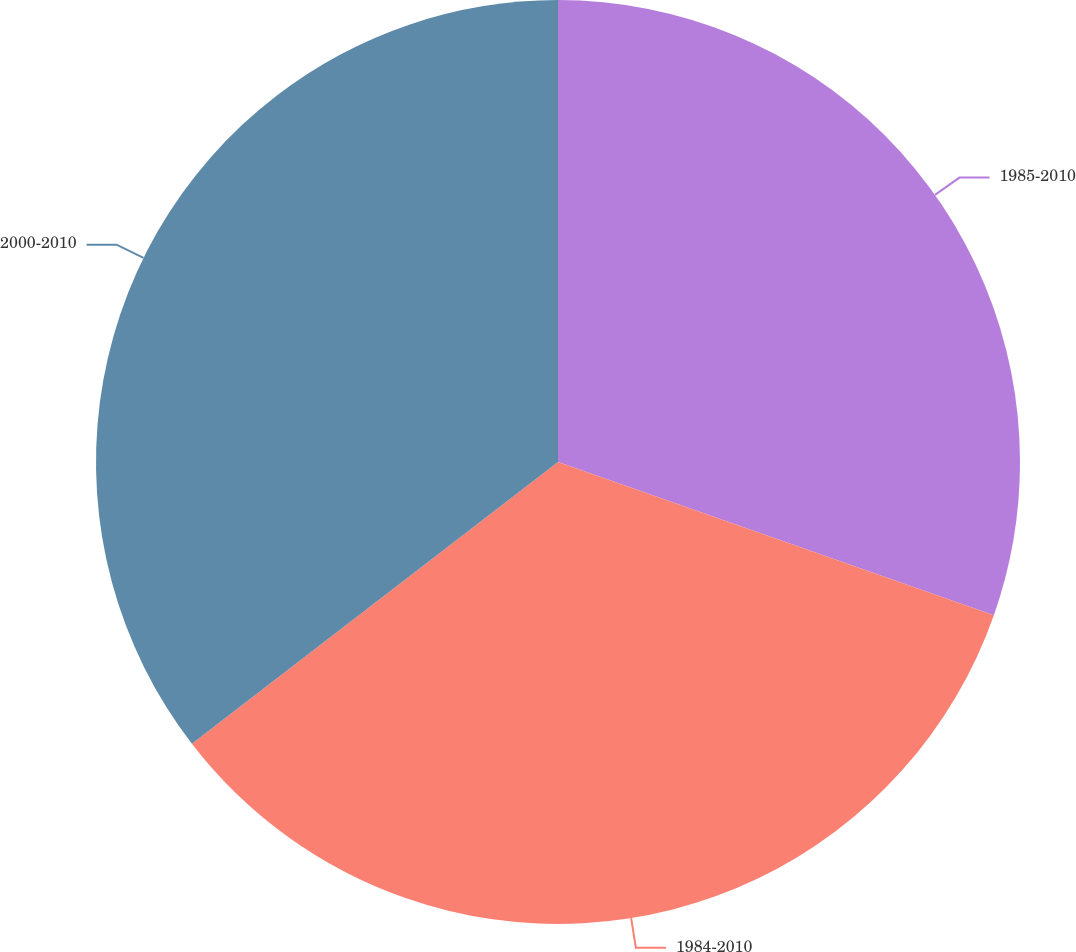Convert chart. <chart><loc_0><loc_0><loc_500><loc_500><pie_chart><fcel>1985-2010<fcel>1984-2010<fcel>2000-2010<nl><fcel>30.38%<fcel>34.18%<fcel>35.44%<nl></chart> 